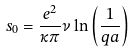<formula> <loc_0><loc_0><loc_500><loc_500>s _ { 0 } = \frac { e ^ { 2 } } { \kappa \pi } \nu \ln \left ( \frac { 1 } { q a } \right )</formula> 